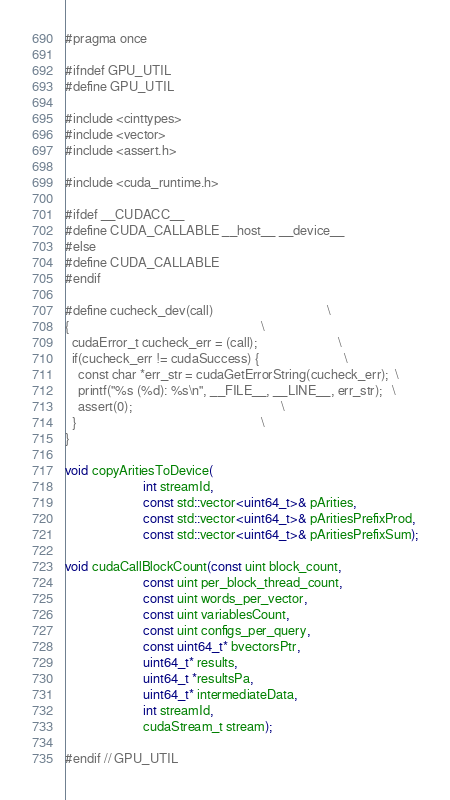Convert code to text. <code><loc_0><loc_0><loc_500><loc_500><_Cuda_>#pragma once

#ifndef GPU_UTIL
#define GPU_UTIL

#include <cinttypes>
#include <vector>
#include <assert.h>

#include <cuda_runtime.h>

#ifdef __CUDACC__
#define CUDA_CALLABLE __host__ __device__
#else
#define CUDA_CALLABLE
#endif

#define cucheck_dev(call)                                   \
{                                                           \
  cudaError_t cucheck_err = (call);                         \
  if(cucheck_err != cudaSuccess) {                          \
    const char *err_str = cudaGetErrorString(cucheck_err);  \
    printf("%s (%d): %s\n", __FILE__, __LINE__, err_str);   \
    assert(0);                                              \
  }                                                         \
}

void copyAritiesToDevice(
                        int streamId,
                        const std::vector<uint64_t>& pArities,
                        const std::vector<uint64_t>& pAritiesPrefixProd,
                        const std::vector<uint64_t>& pAritiesPrefixSum);

void cudaCallBlockCount(const uint block_count,
                        const uint per_block_thread_count,
                        const uint words_per_vector,
                        const uint variablesCount,
                        const uint configs_per_query,
                        const uint64_t* bvectorsPtr,
                        uint64_t* results,
                        uint64_t *resultsPa,
                        uint64_t* intermediateData,
                        int streamId,
                        cudaStream_t stream);

#endif // GPU_UTIL
</code> 